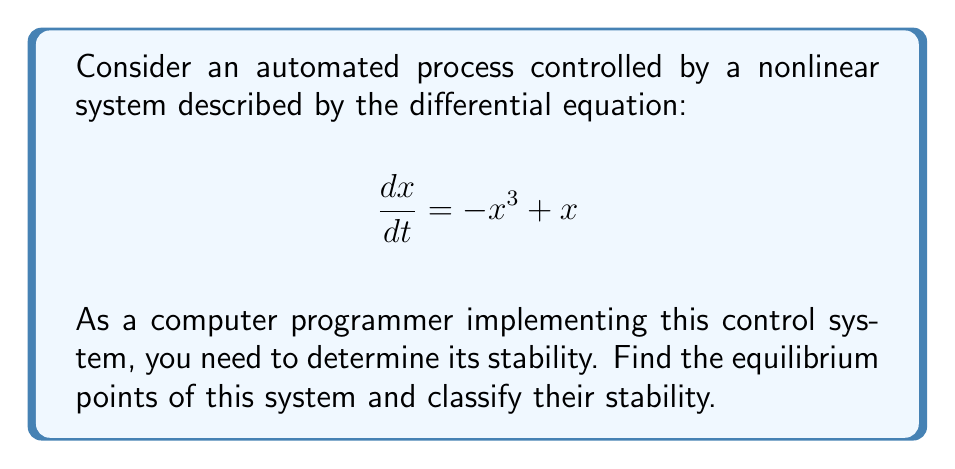Can you solve this math problem? 1. Find the equilibrium points:
   Set $\frac{dx}{dt} = 0$ and solve for $x$:
   $$-x^3 + x = 0$$
   $$x(-x^2 + 1) = 0$$
   $$x(1-x)(1+x) = 0$$
   Equilibrium points: $x = -1, 0, 1$

2. Analyze stability using linearization:
   $f(x) = -x^3 + x$
   $f'(x) = -3x^2 + 1$

3. Evaluate $f'(x)$ at each equilibrium point:
   At $x = -1$: $f'(-1) = -2$
   At $x = 0$: $f'(0) = 1$
   At $x = 1$: $f'(1) = -2$

4. Classify stability:
   - For $x = -1$ and $x = 1$: $f'(x) < 0$, so these are stable equilibrium points.
   - For $x = 0$: $f'(x) > 0$, so this is an unstable equilibrium point.

5. Verify with phase portrait:
   [asy]
   import graph;
   size(200,200);
   
   real f(real x) {return -x^3+x;}
   
   draw(graph(f,-2,2),blue);
   draw((-2,0)--(2,0),gray);
   draw((0,-1)--(0,1),gray);
   
   dot((-1,0),red);
   dot((0,0),red);
   dot((1,0),red);
   
   label("Stable",(1,0.2),N);
   label("Unstable",(0,0.2),N);
   label("Stable",(-1,0.2),N);
   [/asy]

The phase portrait confirms our analysis, showing the flow towards the stable points and away from the unstable point.
Answer: Stable equilibria: $x = -1, 1$; Unstable equilibrium: $x = 0$ 